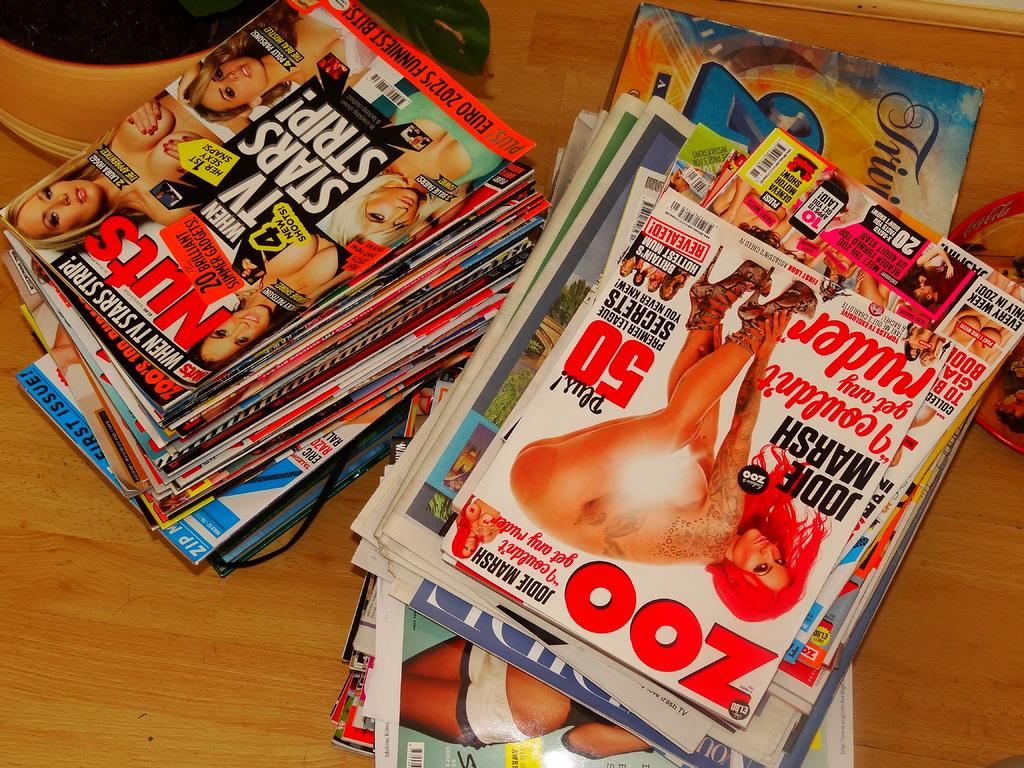<image>
Relay a brief, clear account of the picture shown. Two stacks of adult magazines on the floor with one titled Nuts. 